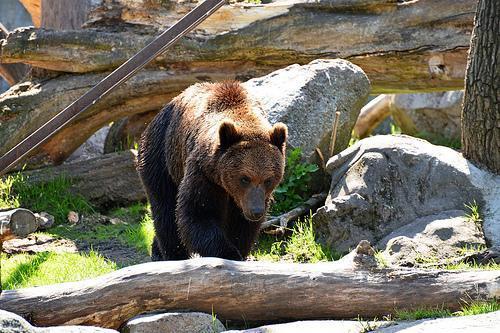How many bears are there?
Give a very brief answer. 1. 